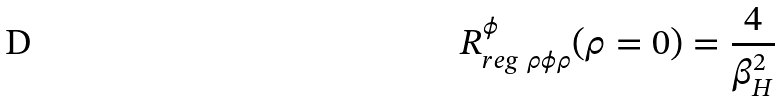Convert formula to latex. <formula><loc_0><loc_0><loc_500><loc_500>R _ { r e g \ \rho \phi \rho } ^ { \phi } ( \rho = 0 ) = { \frac { 4 } { \beta _ { H } ^ { 2 } } }</formula> 